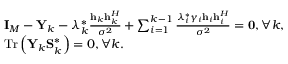Convert formula to latex. <formula><loc_0><loc_0><loc_500><loc_500>\begin{array} { r l } & { { { I } _ { M } } - { { Y } _ { k } } - \lambda _ { k } ^ { * } \frac { { { { h } _ { k } } { h } _ { k } ^ { H } } } { { { \sigma ^ { 2 } } } } + \sum _ { i = 1 } ^ { k - 1 } { \frac { { \lambda _ { i } ^ { * } { \gamma _ { i } } { { h } _ { i } } { h } _ { i } ^ { H } } } { { { \sigma ^ { 2 } } } } } = { 0 } , \forall k , } \\ & { { T r } \left ( { { { Y } _ { k } } { S } _ { k } ^ { * } } \right ) = 0 , \forall k . } \end{array}</formula> 